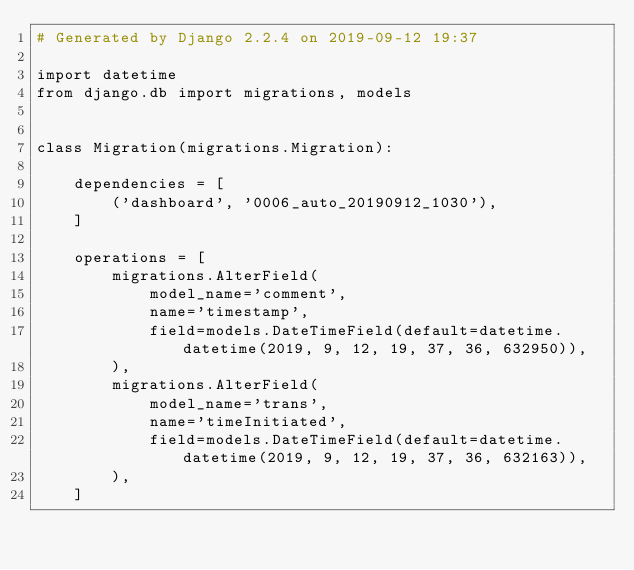<code> <loc_0><loc_0><loc_500><loc_500><_Python_># Generated by Django 2.2.4 on 2019-09-12 19:37

import datetime
from django.db import migrations, models


class Migration(migrations.Migration):

    dependencies = [
        ('dashboard', '0006_auto_20190912_1030'),
    ]

    operations = [
        migrations.AlterField(
            model_name='comment',
            name='timestamp',
            field=models.DateTimeField(default=datetime.datetime(2019, 9, 12, 19, 37, 36, 632950)),
        ),
        migrations.AlterField(
            model_name='trans',
            name='timeInitiated',
            field=models.DateTimeField(default=datetime.datetime(2019, 9, 12, 19, 37, 36, 632163)),
        ),
    ]
</code> 